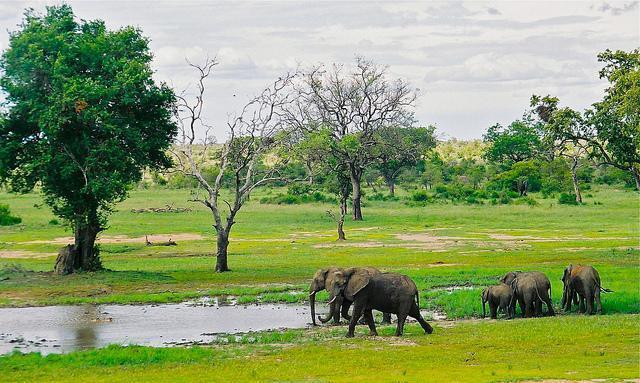What is next to the elephant?
From the following four choices, select the correct answer to address the question.
Options: Baby wolf, bear, trainer, water. Water. 